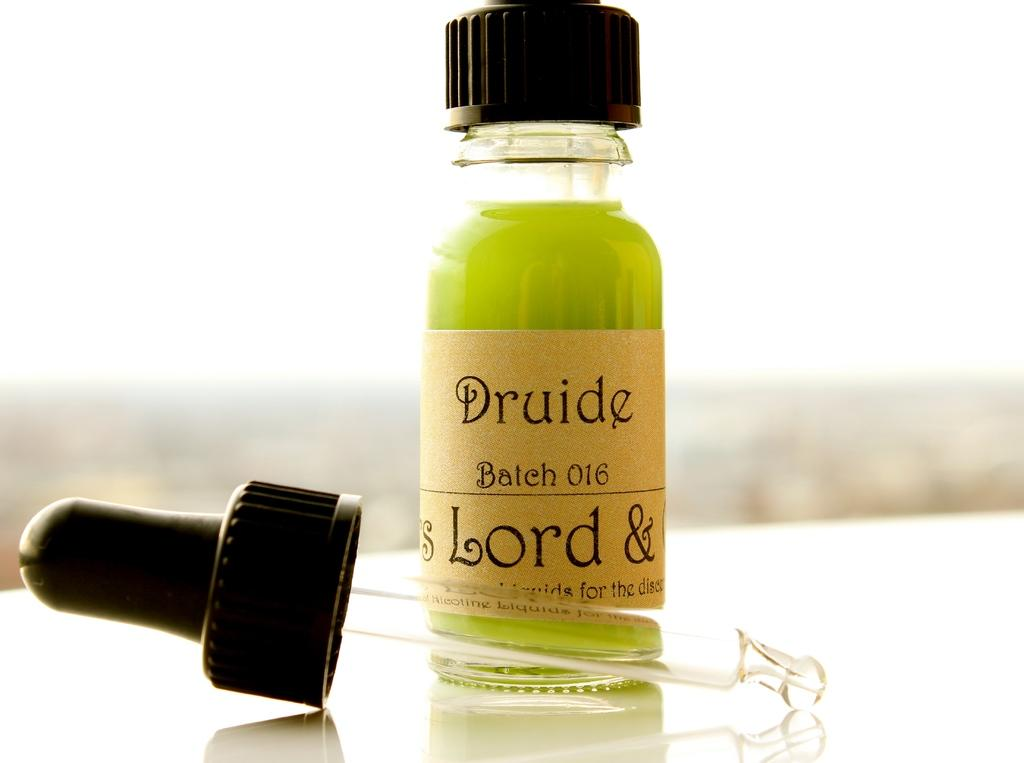Provide a one-sentence caption for the provided image. A bottle of green druide fluid with its dropper in front of it. 